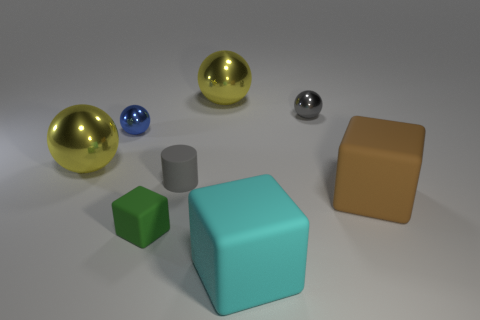What is the material of the thing that is in front of the gray sphere and on the right side of the large cyan rubber thing?
Ensure brevity in your answer.  Rubber. Are there the same number of gray matte things that are in front of the tiny green block and cyan metal blocks?
Provide a succinct answer. Yes. How many small blue objects are the same shape as the gray matte thing?
Your answer should be compact. 0. There is a rubber cube that is on the right side of the metal object to the right of the big metallic thing on the right side of the gray matte object; how big is it?
Keep it short and to the point. Large. Are the large thing to the right of the tiny gray sphere and the cylinder made of the same material?
Your answer should be compact. Yes. Is the number of metallic spheres that are on the right side of the tiny blue metal ball the same as the number of small blue shiny spheres right of the big brown rubber thing?
Offer a terse response. No. Is there any other thing that is the same size as the brown block?
Offer a very short reply. Yes. There is a small blue thing that is the same shape as the small gray shiny object; what is its material?
Make the answer very short. Metal. There is a large metallic object that is behind the small blue thing that is on the left side of the gray matte cylinder; is there a rubber block that is to the right of it?
Provide a succinct answer. Yes. Is the shape of the big yellow thing to the right of the green cube the same as the big object that is in front of the big brown rubber block?
Make the answer very short. No. 